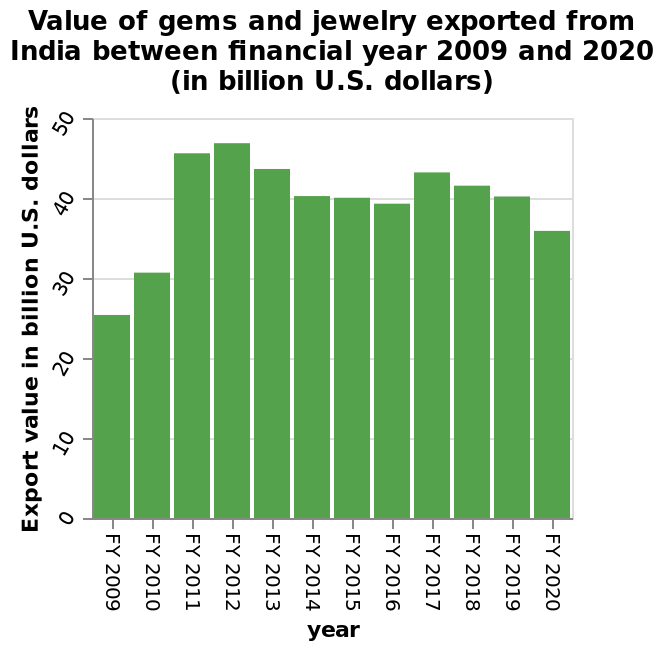<image>
Does the value of exported gems and jewellery from India fluctuates over the years? The given information does not specify if the value of exported gems and jewellery from India fluctuates over the years. Offer a thorough analysis of the image. From 2009 to 2012 the value of gems exported rose and hit its peak at over 45 billion USD. Between 2013 and 2016 there was a decline which then started to rise again briefly in 2017 before declining once again. 2020 was the lowest value of exportations in the previous 9 years. 